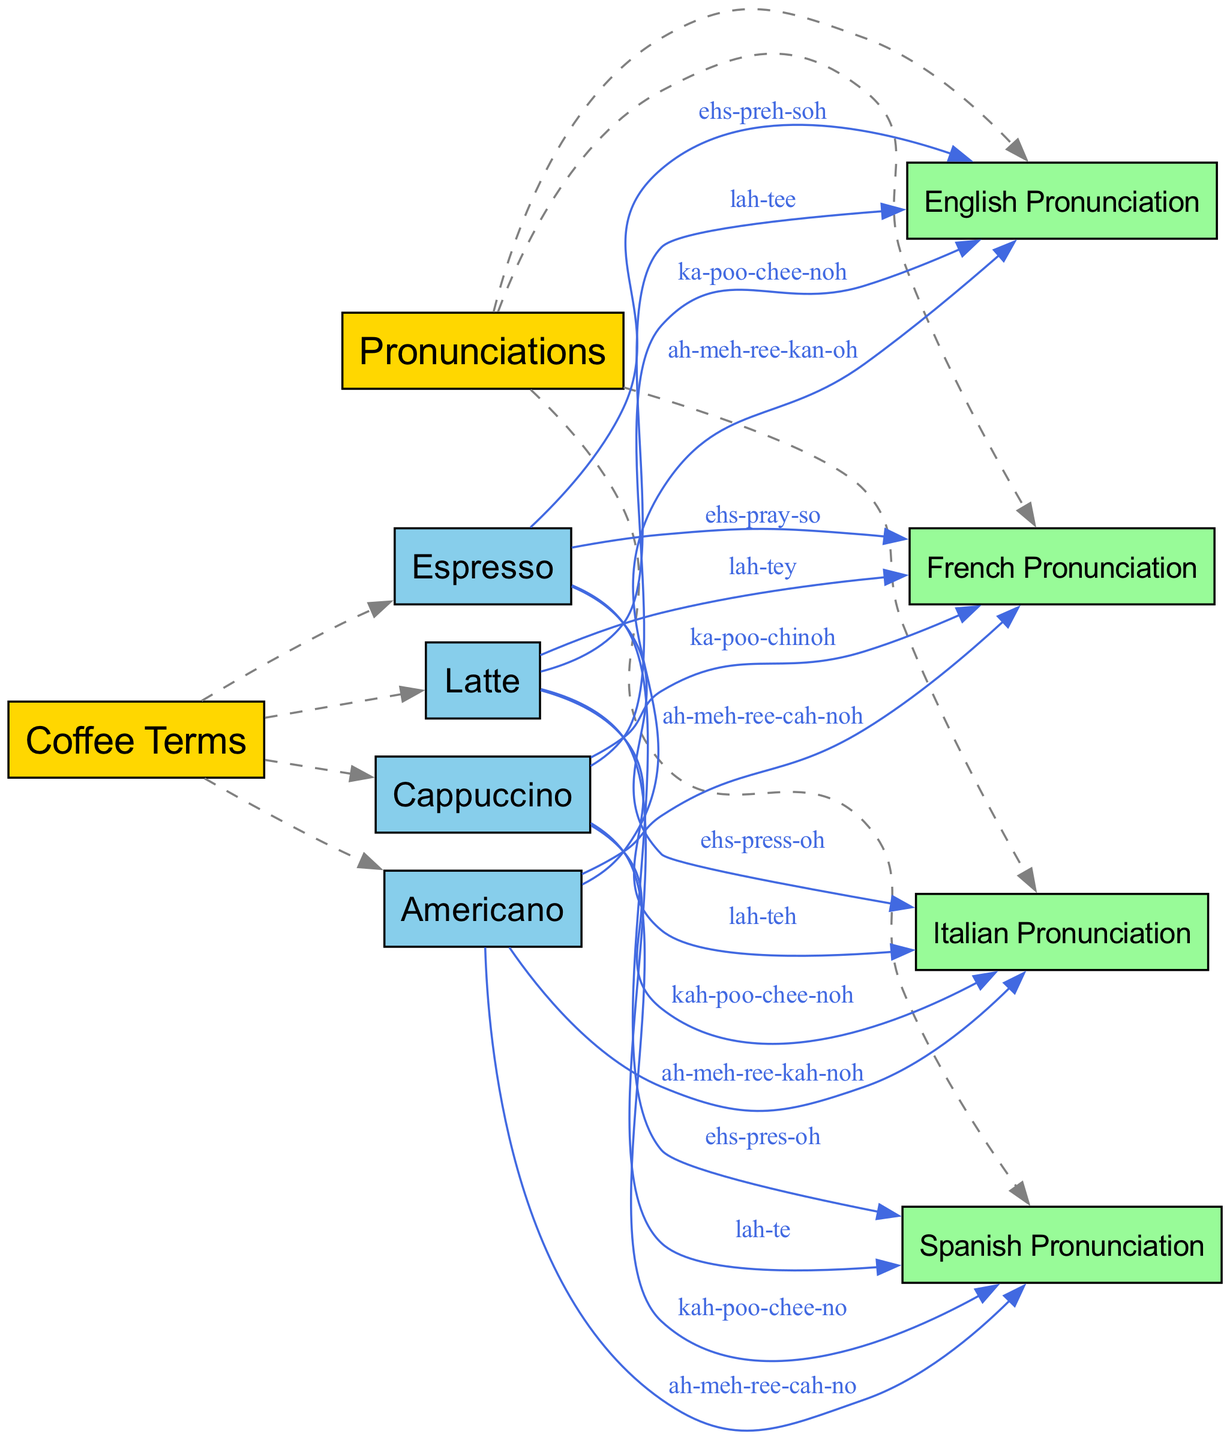What coffee terms are included in the diagram? The diagram lists multiple coffee terms as nodes connected to the "Coffee Terms" category node. These terms are: Latte, Espresso, Cappuccino, and Americano.
Answer: Latte, Espresso, Cappuccino, Americano How many pronunciations categories are included? The diagram connects four nodes representing different pronunciations to the "Pronunciations" category node. These categories are: Italian, French, Spanish, and English. Counting these gives us a total of four pronunciation categories.
Answer: Four What is the English pronunciation for "Latte"? The diagram shows a specific edge connecting "Latte" to "English Pronunciation" with the label "lah-tee." Therefore, this is how "Latte" is pronounced in English.
Answer: lah-tee Which coffee term has the Italian pronunciation "kah-poo-chee-noh"? By examining the edges extending from the "Cappuccino" node, we see that it connects to "Italian Pronunciation" with the label "kah-poo-chee-noh." This indicates that "Cappuccino" has this specific Italian pronunciation.
Answer: Cappuccino What distinguishes the Spanish pronunciation of "Americano" from the English pronunciation? In the diagram, "Americano" has two edges leading to language nodes: one to "Spanish Pronunciation" labeled "ah-meh-ree-cah-no" and another to "English Pronunciation" labeled "ah-meh-ree-kan-oh." The difference lies in the final syllable, where the Spanish version ends with "no" and the English version ends with "kan-oh."
Answer: The ending syllable differences What is shared among all coffee terms in this diagram? Each of the coffee terms "Latte," "Espresso," "Cappuccino," and "Americano" is linked to the "Coffee Terms" node via the "includes" relationship. This indicates that they are all considered under the broader category of coffee terms.
Answer: They are all included under coffee terms 